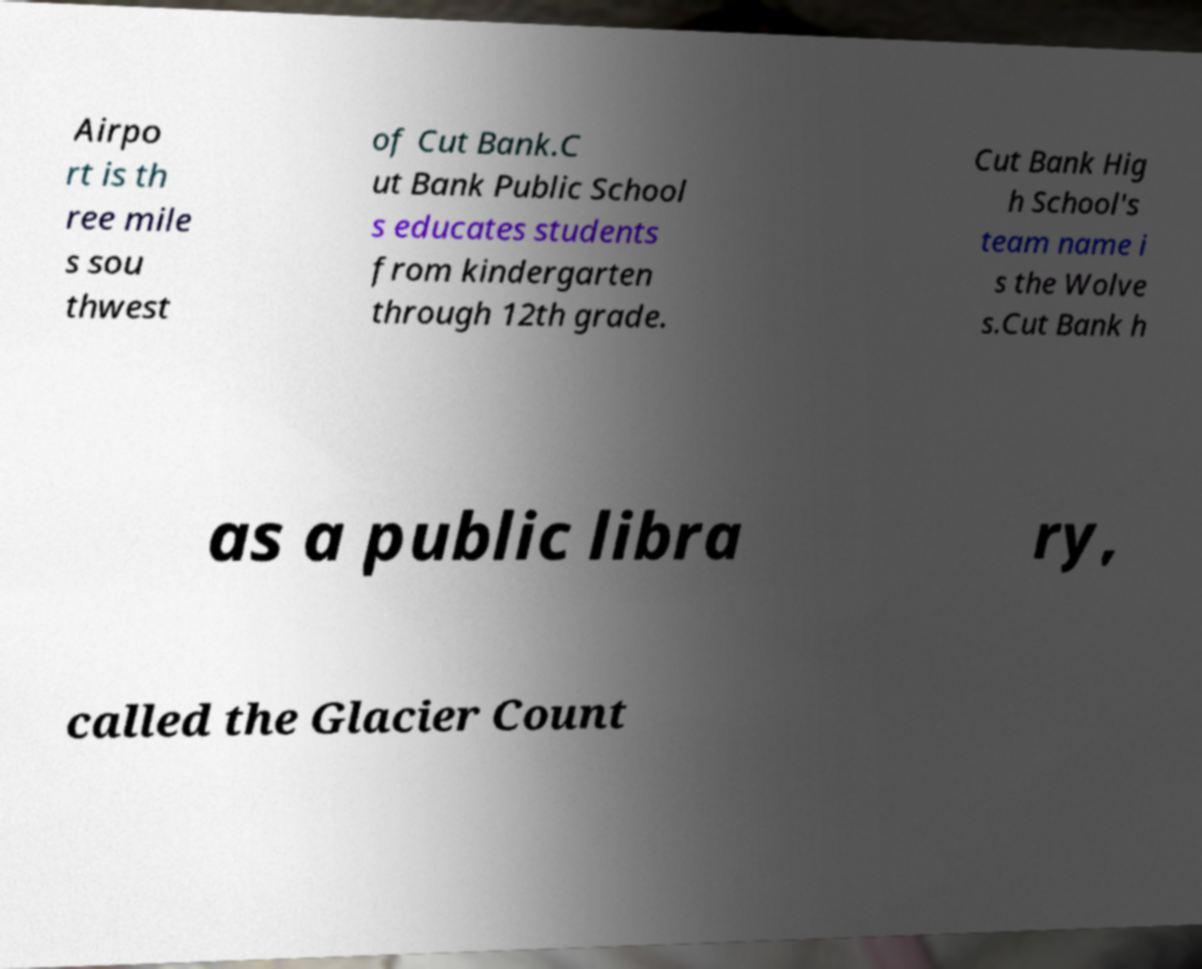Can you read and provide the text displayed in the image?This photo seems to have some interesting text. Can you extract and type it out for me? Airpo rt is th ree mile s sou thwest of Cut Bank.C ut Bank Public School s educates students from kindergarten through 12th grade. Cut Bank Hig h School's team name i s the Wolve s.Cut Bank h as a public libra ry, called the Glacier Count 